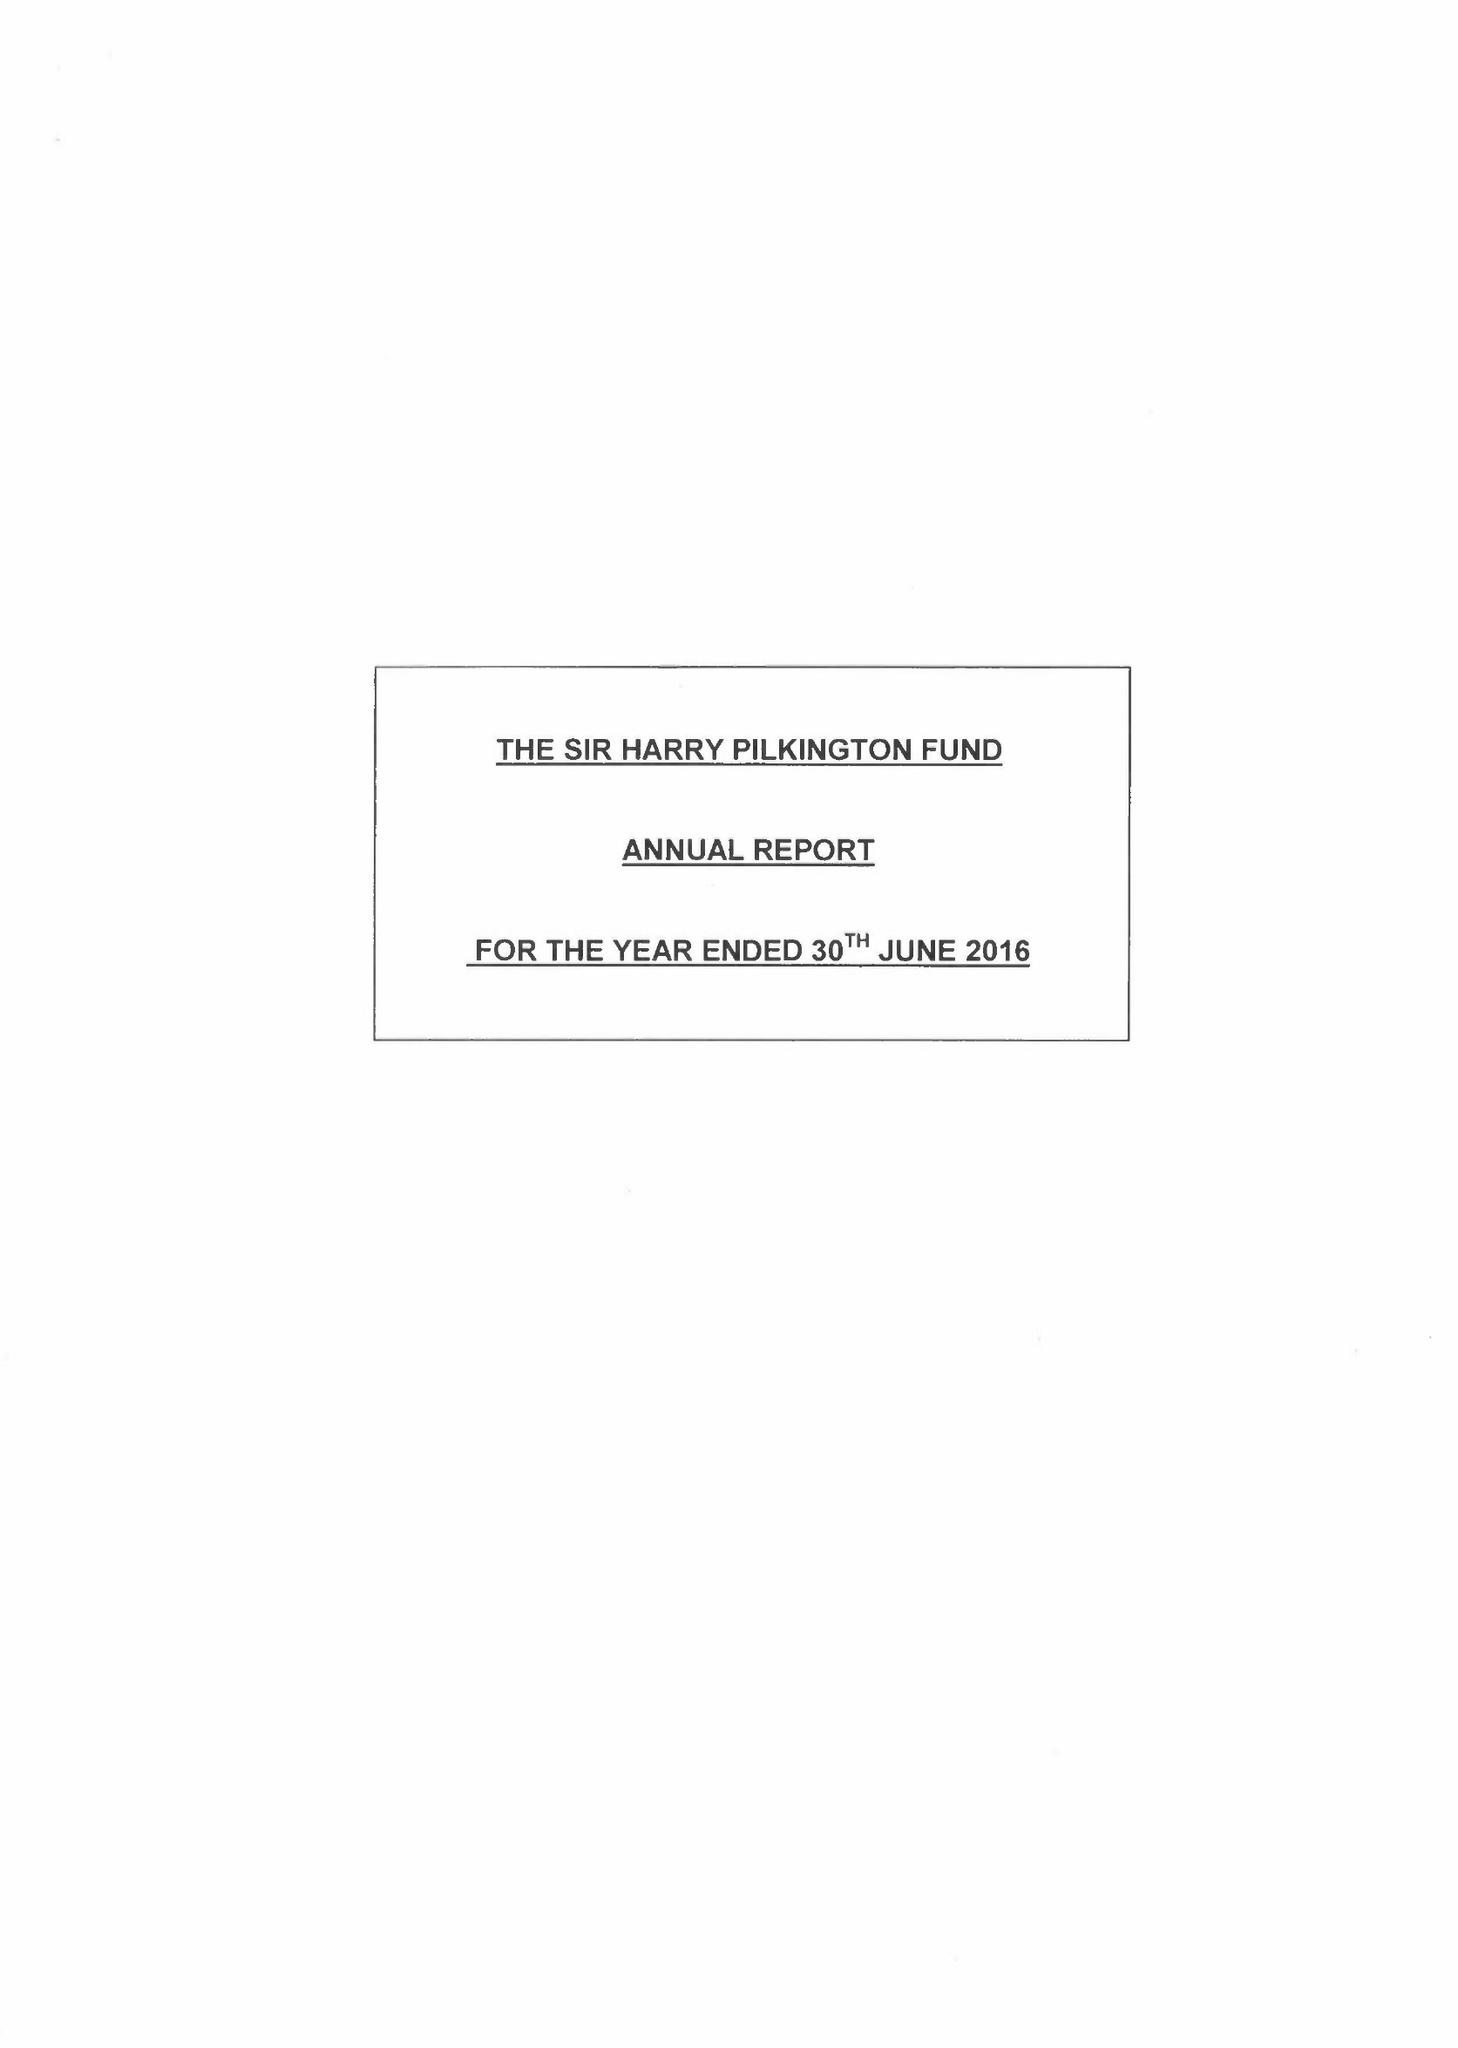What is the value for the report_date?
Answer the question using a single word or phrase. 2016-06-30 